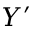<formula> <loc_0><loc_0><loc_500><loc_500>Y ^ { \prime }</formula> 